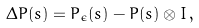<formula> <loc_0><loc_0><loc_500><loc_500>\Delta P ( s ) = P _ { \epsilon } ( s ) - P ( s ) \otimes I \, ,</formula> 